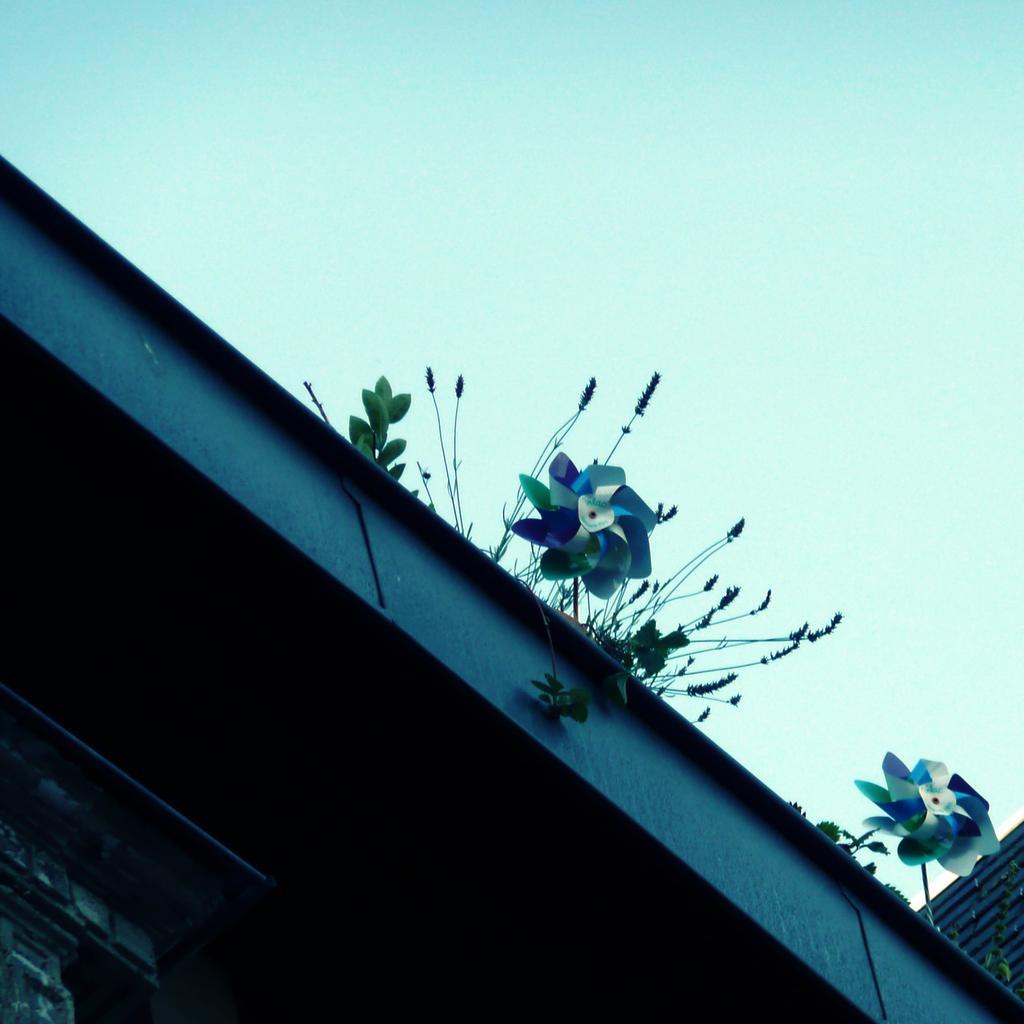How would you summarize this image in a sentence or two? At the bottom of the picture it is building. In the center of the picture there are fan like objects and plants. At the top sky. 